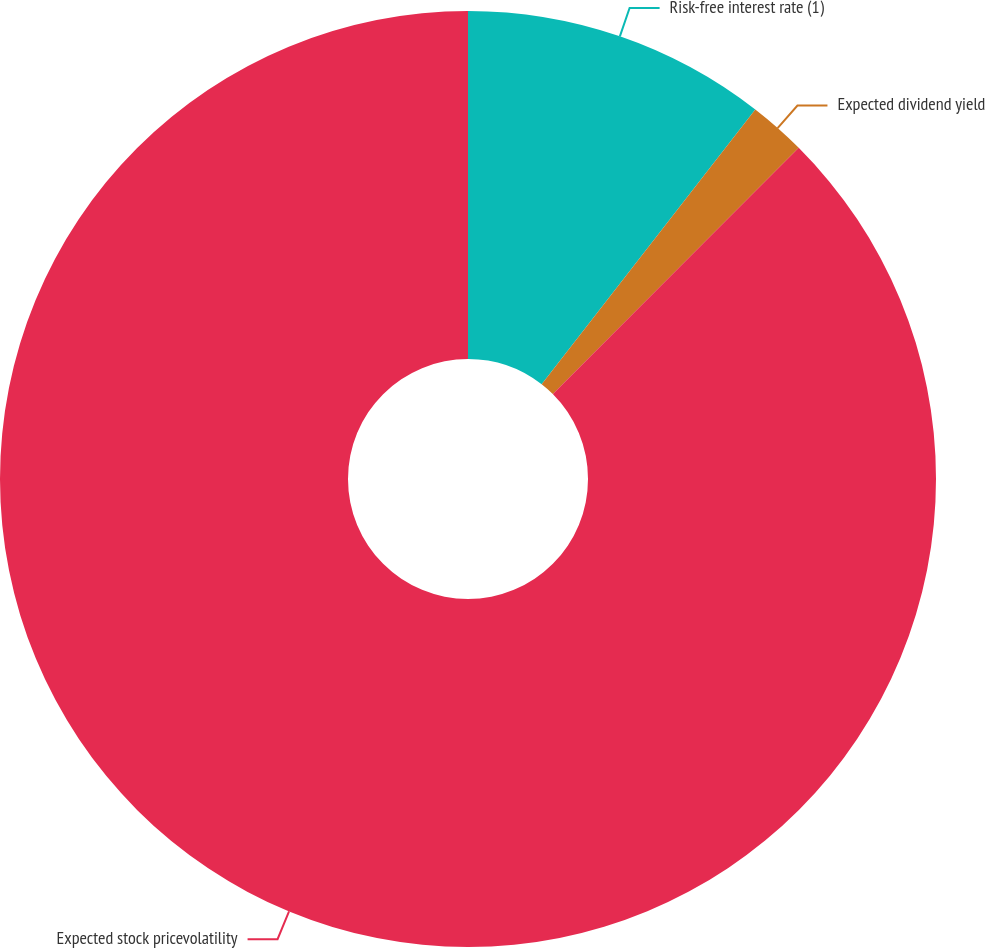<chart> <loc_0><loc_0><loc_500><loc_500><pie_chart><fcel>Risk-free interest rate (1)<fcel>Expected dividend yield<fcel>Expected stock pricevolatility<nl><fcel>10.52%<fcel>1.97%<fcel>87.51%<nl></chart> 